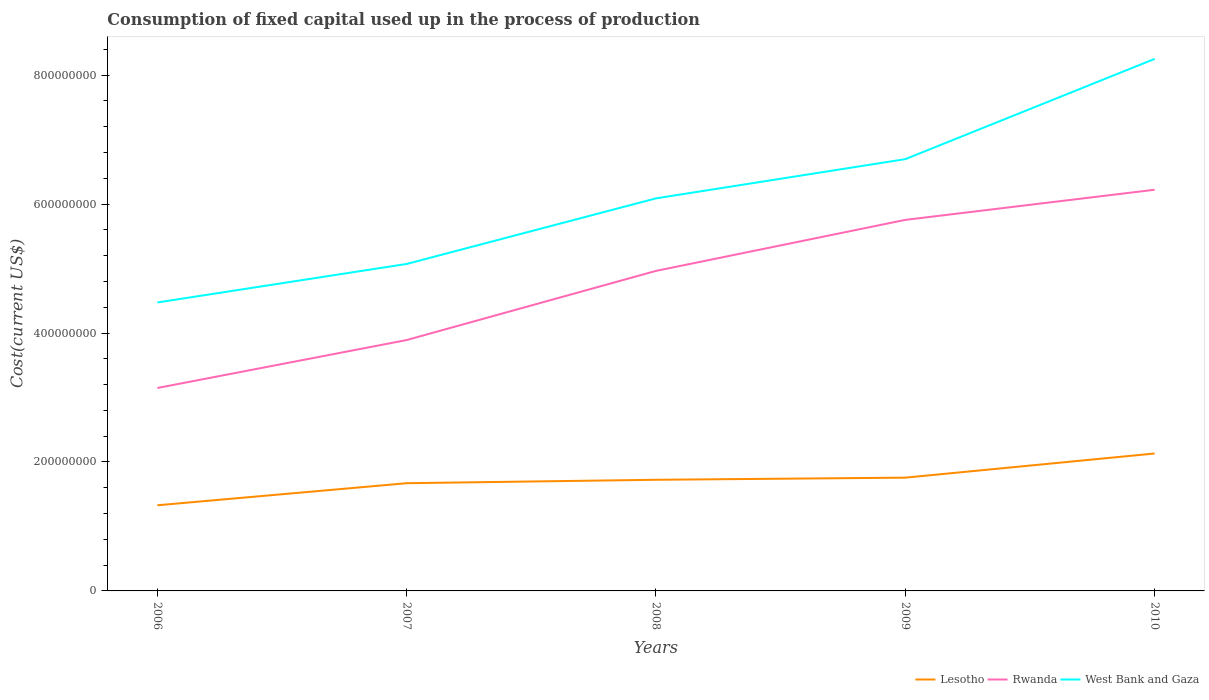Does the line corresponding to Rwanda intersect with the line corresponding to West Bank and Gaza?
Your answer should be compact. No. Is the number of lines equal to the number of legend labels?
Offer a terse response. Yes. Across all years, what is the maximum amount consumed in the process of production in Lesotho?
Offer a very short reply. 1.33e+08. What is the total amount consumed in the process of production in Lesotho in the graph?
Ensure brevity in your answer.  -3.75e+07. What is the difference between the highest and the second highest amount consumed in the process of production in Rwanda?
Offer a very short reply. 3.07e+08. What is the difference between the highest and the lowest amount consumed in the process of production in West Bank and Gaza?
Make the answer very short. 2. What is the difference between two consecutive major ticks on the Y-axis?
Ensure brevity in your answer.  2.00e+08. Are the values on the major ticks of Y-axis written in scientific E-notation?
Provide a short and direct response. No. Does the graph contain any zero values?
Offer a terse response. No. Does the graph contain grids?
Provide a succinct answer. No. How many legend labels are there?
Give a very brief answer. 3. How are the legend labels stacked?
Provide a short and direct response. Horizontal. What is the title of the graph?
Offer a very short reply. Consumption of fixed capital used up in the process of production. Does "Botswana" appear as one of the legend labels in the graph?
Your answer should be compact. No. What is the label or title of the X-axis?
Offer a terse response. Years. What is the label or title of the Y-axis?
Keep it short and to the point. Cost(current US$). What is the Cost(current US$) of Lesotho in 2006?
Provide a succinct answer. 1.33e+08. What is the Cost(current US$) in Rwanda in 2006?
Keep it short and to the point. 3.15e+08. What is the Cost(current US$) of West Bank and Gaza in 2006?
Give a very brief answer. 4.47e+08. What is the Cost(current US$) in Lesotho in 2007?
Your answer should be compact. 1.67e+08. What is the Cost(current US$) in Rwanda in 2007?
Give a very brief answer. 3.89e+08. What is the Cost(current US$) in West Bank and Gaza in 2007?
Give a very brief answer. 5.07e+08. What is the Cost(current US$) of Lesotho in 2008?
Make the answer very short. 1.72e+08. What is the Cost(current US$) in Rwanda in 2008?
Your answer should be compact. 4.96e+08. What is the Cost(current US$) in West Bank and Gaza in 2008?
Offer a very short reply. 6.09e+08. What is the Cost(current US$) of Lesotho in 2009?
Your answer should be very brief. 1.76e+08. What is the Cost(current US$) of Rwanda in 2009?
Give a very brief answer. 5.75e+08. What is the Cost(current US$) in West Bank and Gaza in 2009?
Your answer should be very brief. 6.70e+08. What is the Cost(current US$) in Lesotho in 2010?
Make the answer very short. 2.13e+08. What is the Cost(current US$) in Rwanda in 2010?
Your response must be concise. 6.22e+08. What is the Cost(current US$) of West Bank and Gaza in 2010?
Give a very brief answer. 8.25e+08. Across all years, what is the maximum Cost(current US$) of Lesotho?
Keep it short and to the point. 2.13e+08. Across all years, what is the maximum Cost(current US$) of Rwanda?
Your answer should be compact. 6.22e+08. Across all years, what is the maximum Cost(current US$) in West Bank and Gaza?
Give a very brief answer. 8.25e+08. Across all years, what is the minimum Cost(current US$) in Lesotho?
Provide a succinct answer. 1.33e+08. Across all years, what is the minimum Cost(current US$) in Rwanda?
Offer a terse response. 3.15e+08. Across all years, what is the minimum Cost(current US$) of West Bank and Gaza?
Your answer should be very brief. 4.47e+08. What is the total Cost(current US$) in Lesotho in the graph?
Offer a very short reply. 8.61e+08. What is the total Cost(current US$) of Rwanda in the graph?
Keep it short and to the point. 2.40e+09. What is the total Cost(current US$) in West Bank and Gaza in the graph?
Offer a terse response. 3.06e+09. What is the difference between the Cost(current US$) in Lesotho in 2006 and that in 2007?
Provide a short and direct response. -3.42e+07. What is the difference between the Cost(current US$) of Rwanda in 2006 and that in 2007?
Your response must be concise. -7.44e+07. What is the difference between the Cost(current US$) of West Bank and Gaza in 2006 and that in 2007?
Make the answer very short. -5.97e+07. What is the difference between the Cost(current US$) in Lesotho in 2006 and that in 2008?
Provide a succinct answer. -3.95e+07. What is the difference between the Cost(current US$) in Rwanda in 2006 and that in 2008?
Your response must be concise. -1.82e+08. What is the difference between the Cost(current US$) of West Bank and Gaza in 2006 and that in 2008?
Provide a succinct answer. -1.61e+08. What is the difference between the Cost(current US$) in Lesotho in 2006 and that in 2009?
Offer a terse response. -4.28e+07. What is the difference between the Cost(current US$) in Rwanda in 2006 and that in 2009?
Provide a succinct answer. -2.61e+08. What is the difference between the Cost(current US$) of West Bank and Gaza in 2006 and that in 2009?
Give a very brief answer. -2.22e+08. What is the difference between the Cost(current US$) in Lesotho in 2006 and that in 2010?
Your answer should be very brief. -8.03e+07. What is the difference between the Cost(current US$) in Rwanda in 2006 and that in 2010?
Keep it short and to the point. -3.07e+08. What is the difference between the Cost(current US$) of West Bank and Gaza in 2006 and that in 2010?
Ensure brevity in your answer.  -3.78e+08. What is the difference between the Cost(current US$) in Lesotho in 2007 and that in 2008?
Your answer should be compact. -5.32e+06. What is the difference between the Cost(current US$) of Rwanda in 2007 and that in 2008?
Provide a succinct answer. -1.07e+08. What is the difference between the Cost(current US$) of West Bank and Gaza in 2007 and that in 2008?
Your answer should be compact. -1.02e+08. What is the difference between the Cost(current US$) of Lesotho in 2007 and that in 2009?
Provide a succinct answer. -8.62e+06. What is the difference between the Cost(current US$) of Rwanda in 2007 and that in 2009?
Keep it short and to the point. -1.86e+08. What is the difference between the Cost(current US$) of West Bank and Gaza in 2007 and that in 2009?
Make the answer very short. -1.63e+08. What is the difference between the Cost(current US$) of Lesotho in 2007 and that in 2010?
Your answer should be very brief. -4.61e+07. What is the difference between the Cost(current US$) in Rwanda in 2007 and that in 2010?
Make the answer very short. -2.33e+08. What is the difference between the Cost(current US$) in West Bank and Gaza in 2007 and that in 2010?
Make the answer very short. -3.18e+08. What is the difference between the Cost(current US$) in Lesotho in 2008 and that in 2009?
Your response must be concise. -3.30e+06. What is the difference between the Cost(current US$) in Rwanda in 2008 and that in 2009?
Your response must be concise. -7.91e+07. What is the difference between the Cost(current US$) of West Bank and Gaza in 2008 and that in 2009?
Ensure brevity in your answer.  -6.08e+07. What is the difference between the Cost(current US$) in Lesotho in 2008 and that in 2010?
Keep it short and to the point. -4.08e+07. What is the difference between the Cost(current US$) in Rwanda in 2008 and that in 2010?
Give a very brief answer. -1.26e+08. What is the difference between the Cost(current US$) of West Bank and Gaza in 2008 and that in 2010?
Offer a very short reply. -2.16e+08. What is the difference between the Cost(current US$) of Lesotho in 2009 and that in 2010?
Your response must be concise. -3.75e+07. What is the difference between the Cost(current US$) of Rwanda in 2009 and that in 2010?
Ensure brevity in your answer.  -4.68e+07. What is the difference between the Cost(current US$) of West Bank and Gaza in 2009 and that in 2010?
Make the answer very short. -1.55e+08. What is the difference between the Cost(current US$) in Lesotho in 2006 and the Cost(current US$) in Rwanda in 2007?
Keep it short and to the point. -2.56e+08. What is the difference between the Cost(current US$) of Lesotho in 2006 and the Cost(current US$) of West Bank and Gaza in 2007?
Your response must be concise. -3.74e+08. What is the difference between the Cost(current US$) in Rwanda in 2006 and the Cost(current US$) in West Bank and Gaza in 2007?
Your answer should be compact. -1.92e+08. What is the difference between the Cost(current US$) in Lesotho in 2006 and the Cost(current US$) in Rwanda in 2008?
Ensure brevity in your answer.  -3.63e+08. What is the difference between the Cost(current US$) in Lesotho in 2006 and the Cost(current US$) in West Bank and Gaza in 2008?
Provide a succinct answer. -4.76e+08. What is the difference between the Cost(current US$) of Rwanda in 2006 and the Cost(current US$) of West Bank and Gaza in 2008?
Make the answer very short. -2.94e+08. What is the difference between the Cost(current US$) of Lesotho in 2006 and the Cost(current US$) of Rwanda in 2009?
Ensure brevity in your answer.  -4.43e+08. What is the difference between the Cost(current US$) in Lesotho in 2006 and the Cost(current US$) in West Bank and Gaza in 2009?
Your answer should be very brief. -5.37e+08. What is the difference between the Cost(current US$) in Rwanda in 2006 and the Cost(current US$) in West Bank and Gaza in 2009?
Keep it short and to the point. -3.55e+08. What is the difference between the Cost(current US$) in Lesotho in 2006 and the Cost(current US$) in Rwanda in 2010?
Your response must be concise. -4.89e+08. What is the difference between the Cost(current US$) in Lesotho in 2006 and the Cost(current US$) in West Bank and Gaza in 2010?
Your answer should be compact. -6.92e+08. What is the difference between the Cost(current US$) of Rwanda in 2006 and the Cost(current US$) of West Bank and Gaza in 2010?
Your answer should be very brief. -5.10e+08. What is the difference between the Cost(current US$) of Lesotho in 2007 and the Cost(current US$) of Rwanda in 2008?
Provide a succinct answer. -3.29e+08. What is the difference between the Cost(current US$) of Lesotho in 2007 and the Cost(current US$) of West Bank and Gaza in 2008?
Your answer should be very brief. -4.42e+08. What is the difference between the Cost(current US$) in Rwanda in 2007 and the Cost(current US$) in West Bank and Gaza in 2008?
Keep it short and to the point. -2.20e+08. What is the difference between the Cost(current US$) of Lesotho in 2007 and the Cost(current US$) of Rwanda in 2009?
Offer a very short reply. -4.08e+08. What is the difference between the Cost(current US$) in Lesotho in 2007 and the Cost(current US$) in West Bank and Gaza in 2009?
Ensure brevity in your answer.  -5.03e+08. What is the difference between the Cost(current US$) of Rwanda in 2007 and the Cost(current US$) of West Bank and Gaza in 2009?
Your response must be concise. -2.81e+08. What is the difference between the Cost(current US$) in Lesotho in 2007 and the Cost(current US$) in Rwanda in 2010?
Keep it short and to the point. -4.55e+08. What is the difference between the Cost(current US$) of Lesotho in 2007 and the Cost(current US$) of West Bank and Gaza in 2010?
Offer a terse response. -6.58e+08. What is the difference between the Cost(current US$) in Rwanda in 2007 and the Cost(current US$) in West Bank and Gaza in 2010?
Ensure brevity in your answer.  -4.36e+08. What is the difference between the Cost(current US$) in Lesotho in 2008 and the Cost(current US$) in Rwanda in 2009?
Your answer should be very brief. -4.03e+08. What is the difference between the Cost(current US$) of Lesotho in 2008 and the Cost(current US$) of West Bank and Gaza in 2009?
Offer a very short reply. -4.97e+08. What is the difference between the Cost(current US$) of Rwanda in 2008 and the Cost(current US$) of West Bank and Gaza in 2009?
Provide a short and direct response. -1.73e+08. What is the difference between the Cost(current US$) in Lesotho in 2008 and the Cost(current US$) in Rwanda in 2010?
Offer a terse response. -4.50e+08. What is the difference between the Cost(current US$) of Lesotho in 2008 and the Cost(current US$) of West Bank and Gaza in 2010?
Offer a terse response. -6.53e+08. What is the difference between the Cost(current US$) of Rwanda in 2008 and the Cost(current US$) of West Bank and Gaza in 2010?
Your answer should be very brief. -3.29e+08. What is the difference between the Cost(current US$) in Lesotho in 2009 and the Cost(current US$) in Rwanda in 2010?
Your response must be concise. -4.47e+08. What is the difference between the Cost(current US$) of Lesotho in 2009 and the Cost(current US$) of West Bank and Gaza in 2010?
Ensure brevity in your answer.  -6.49e+08. What is the difference between the Cost(current US$) in Rwanda in 2009 and the Cost(current US$) in West Bank and Gaza in 2010?
Provide a short and direct response. -2.50e+08. What is the average Cost(current US$) of Lesotho per year?
Your answer should be very brief. 1.72e+08. What is the average Cost(current US$) in Rwanda per year?
Ensure brevity in your answer.  4.80e+08. What is the average Cost(current US$) of West Bank and Gaza per year?
Ensure brevity in your answer.  6.12e+08. In the year 2006, what is the difference between the Cost(current US$) of Lesotho and Cost(current US$) of Rwanda?
Your response must be concise. -1.82e+08. In the year 2006, what is the difference between the Cost(current US$) of Lesotho and Cost(current US$) of West Bank and Gaza?
Your response must be concise. -3.15e+08. In the year 2006, what is the difference between the Cost(current US$) of Rwanda and Cost(current US$) of West Bank and Gaza?
Give a very brief answer. -1.33e+08. In the year 2007, what is the difference between the Cost(current US$) in Lesotho and Cost(current US$) in Rwanda?
Keep it short and to the point. -2.22e+08. In the year 2007, what is the difference between the Cost(current US$) in Lesotho and Cost(current US$) in West Bank and Gaza?
Offer a very short reply. -3.40e+08. In the year 2007, what is the difference between the Cost(current US$) of Rwanda and Cost(current US$) of West Bank and Gaza?
Offer a very short reply. -1.18e+08. In the year 2008, what is the difference between the Cost(current US$) in Lesotho and Cost(current US$) in Rwanda?
Make the answer very short. -3.24e+08. In the year 2008, what is the difference between the Cost(current US$) of Lesotho and Cost(current US$) of West Bank and Gaza?
Your response must be concise. -4.36e+08. In the year 2008, what is the difference between the Cost(current US$) in Rwanda and Cost(current US$) in West Bank and Gaza?
Offer a very short reply. -1.12e+08. In the year 2009, what is the difference between the Cost(current US$) of Lesotho and Cost(current US$) of Rwanda?
Your answer should be compact. -4.00e+08. In the year 2009, what is the difference between the Cost(current US$) of Lesotho and Cost(current US$) of West Bank and Gaza?
Your answer should be very brief. -4.94e+08. In the year 2009, what is the difference between the Cost(current US$) of Rwanda and Cost(current US$) of West Bank and Gaza?
Keep it short and to the point. -9.42e+07. In the year 2010, what is the difference between the Cost(current US$) in Lesotho and Cost(current US$) in Rwanda?
Make the answer very short. -4.09e+08. In the year 2010, what is the difference between the Cost(current US$) in Lesotho and Cost(current US$) in West Bank and Gaza?
Keep it short and to the point. -6.12e+08. In the year 2010, what is the difference between the Cost(current US$) in Rwanda and Cost(current US$) in West Bank and Gaza?
Your answer should be very brief. -2.03e+08. What is the ratio of the Cost(current US$) in Lesotho in 2006 to that in 2007?
Your answer should be compact. 0.8. What is the ratio of the Cost(current US$) in Rwanda in 2006 to that in 2007?
Offer a very short reply. 0.81. What is the ratio of the Cost(current US$) of West Bank and Gaza in 2006 to that in 2007?
Keep it short and to the point. 0.88. What is the ratio of the Cost(current US$) in Lesotho in 2006 to that in 2008?
Ensure brevity in your answer.  0.77. What is the ratio of the Cost(current US$) of Rwanda in 2006 to that in 2008?
Offer a terse response. 0.63. What is the ratio of the Cost(current US$) of West Bank and Gaza in 2006 to that in 2008?
Keep it short and to the point. 0.73. What is the ratio of the Cost(current US$) of Lesotho in 2006 to that in 2009?
Offer a very short reply. 0.76. What is the ratio of the Cost(current US$) in Rwanda in 2006 to that in 2009?
Make the answer very short. 0.55. What is the ratio of the Cost(current US$) of West Bank and Gaza in 2006 to that in 2009?
Your response must be concise. 0.67. What is the ratio of the Cost(current US$) in Lesotho in 2006 to that in 2010?
Your answer should be very brief. 0.62. What is the ratio of the Cost(current US$) in Rwanda in 2006 to that in 2010?
Make the answer very short. 0.51. What is the ratio of the Cost(current US$) in West Bank and Gaza in 2006 to that in 2010?
Your answer should be compact. 0.54. What is the ratio of the Cost(current US$) in Lesotho in 2007 to that in 2008?
Provide a short and direct response. 0.97. What is the ratio of the Cost(current US$) of Rwanda in 2007 to that in 2008?
Give a very brief answer. 0.78. What is the ratio of the Cost(current US$) of West Bank and Gaza in 2007 to that in 2008?
Provide a succinct answer. 0.83. What is the ratio of the Cost(current US$) in Lesotho in 2007 to that in 2009?
Give a very brief answer. 0.95. What is the ratio of the Cost(current US$) in Rwanda in 2007 to that in 2009?
Your answer should be compact. 0.68. What is the ratio of the Cost(current US$) of West Bank and Gaza in 2007 to that in 2009?
Your answer should be compact. 0.76. What is the ratio of the Cost(current US$) of Lesotho in 2007 to that in 2010?
Provide a short and direct response. 0.78. What is the ratio of the Cost(current US$) in Rwanda in 2007 to that in 2010?
Give a very brief answer. 0.63. What is the ratio of the Cost(current US$) in West Bank and Gaza in 2007 to that in 2010?
Give a very brief answer. 0.61. What is the ratio of the Cost(current US$) of Lesotho in 2008 to that in 2009?
Provide a succinct answer. 0.98. What is the ratio of the Cost(current US$) in Rwanda in 2008 to that in 2009?
Your answer should be compact. 0.86. What is the ratio of the Cost(current US$) in West Bank and Gaza in 2008 to that in 2009?
Your answer should be very brief. 0.91. What is the ratio of the Cost(current US$) of Lesotho in 2008 to that in 2010?
Your response must be concise. 0.81. What is the ratio of the Cost(current US$) in Rwanda in 2008 to that in 2010?
Make the answer very short. 0.8. What is the ratio of the Cost(current US$) of West Bank and Gaza in 2008 to that in 2010?
Keep it short and to the point. 0.74. What is the ratio of the Cost(current US$) in Lesotho in 2009 to that in 2010?
Your answer should be very brief. 0.82. What is the ratio of the Cost(current US$) in Rwanda in 2009 to that in 2010?
Offer a very short reply. 0.92. What is the ratio of the Cost(current US$) of West Bank and Gaza in 2009 to that in 2010?
Your answer should be compact. 0.81. What is the difference between the highest and the second highest Cost(current US$) of Lesotho?
Provide a short and direct response. 3.75e+07. What is the difference between the highest and the second highest Cost(current US$) in Rwanda?
Give a very brief answer. 4.68e+07. What is the difference between the highest and the second highest Cost(current US$) in West Bank and Gaza?
Ensure brevity in your answer.  1.55e+08. What is the difference between the highest and the lowest Cost(current US$) of Lesotho?
Provide a short and direct response. 8.03e+07. What is the difference between the highest and the lowest Cost(current US$) of Rwanda?
Offer a very short reply. 3.07e+08. What is the difference between the highest and the lowest Cost(current US$) in West Bank and Gaza?
Offer a very short reply. 3.78e+08. 